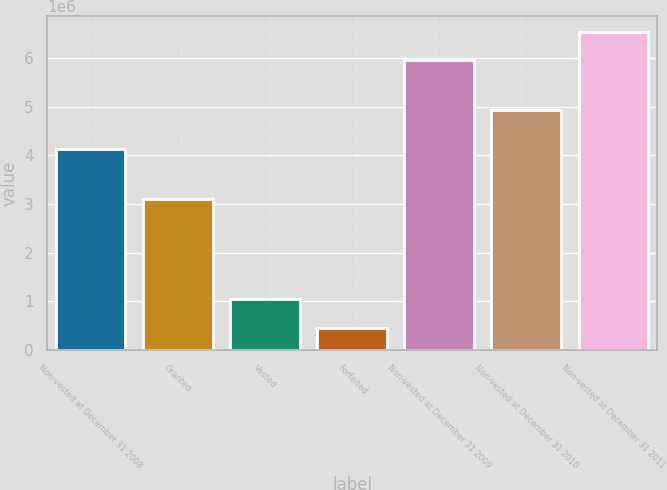Convert chart to OTSL. <chart><loc_0><loc_0><loc_500><loc_500><bar_chart><fcel>Non-vested at December 31 2008<fcel>Granted<fcel>Vested<fcel>Forfeited<fcel>Non-vested at December 31 2009<fcel>Non-vested at December 31 2010<fcel>Non-vested at December 31 2011<nl><fcel>4.12391e+06<fcel>3.10042e+06<fcel>1.03799e+06<fcel>455503<fcel>5.96459e+06<fcel>4.93044e+06<fcel>6.54708e+06<nl></chart> 